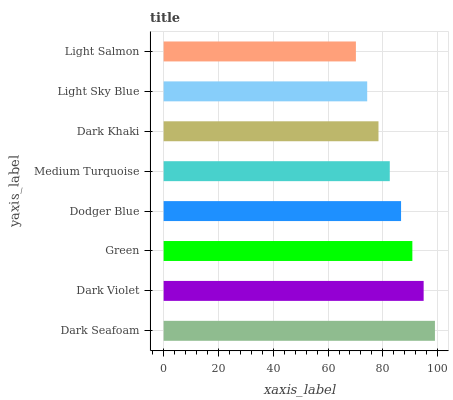Is Light Salmon the minimum?
Answer yes or no. Yes. Is Dark Seafoam the maximum?
Answer yes or no. Yes. Is Dark Violet the minimum?
Answer yes or no. No. Is Dark Violet the maximum?
Answer yes or no. No. Is Dark Seafoam greater than Dark Violet?
Answer yes or no. Yes. Is Dark Violet less than Dark Seafoam?
Answer yes or no. Yes. Is Dark Violet greater than Dark Seafoam?
Answer yes or no. No. Is Dark Seafoam less than Dark Violet?
Answer yes or no. No. Is Dodger Blue the high median?
Answer yes or no. Yes. Is Medium Turquoise the low median?
Answer yes or no. Yes. Is Dark Khaki the high median?
Answer yes or no. No. Is Dodger Blue the low median?
Answer yes or no. No. 